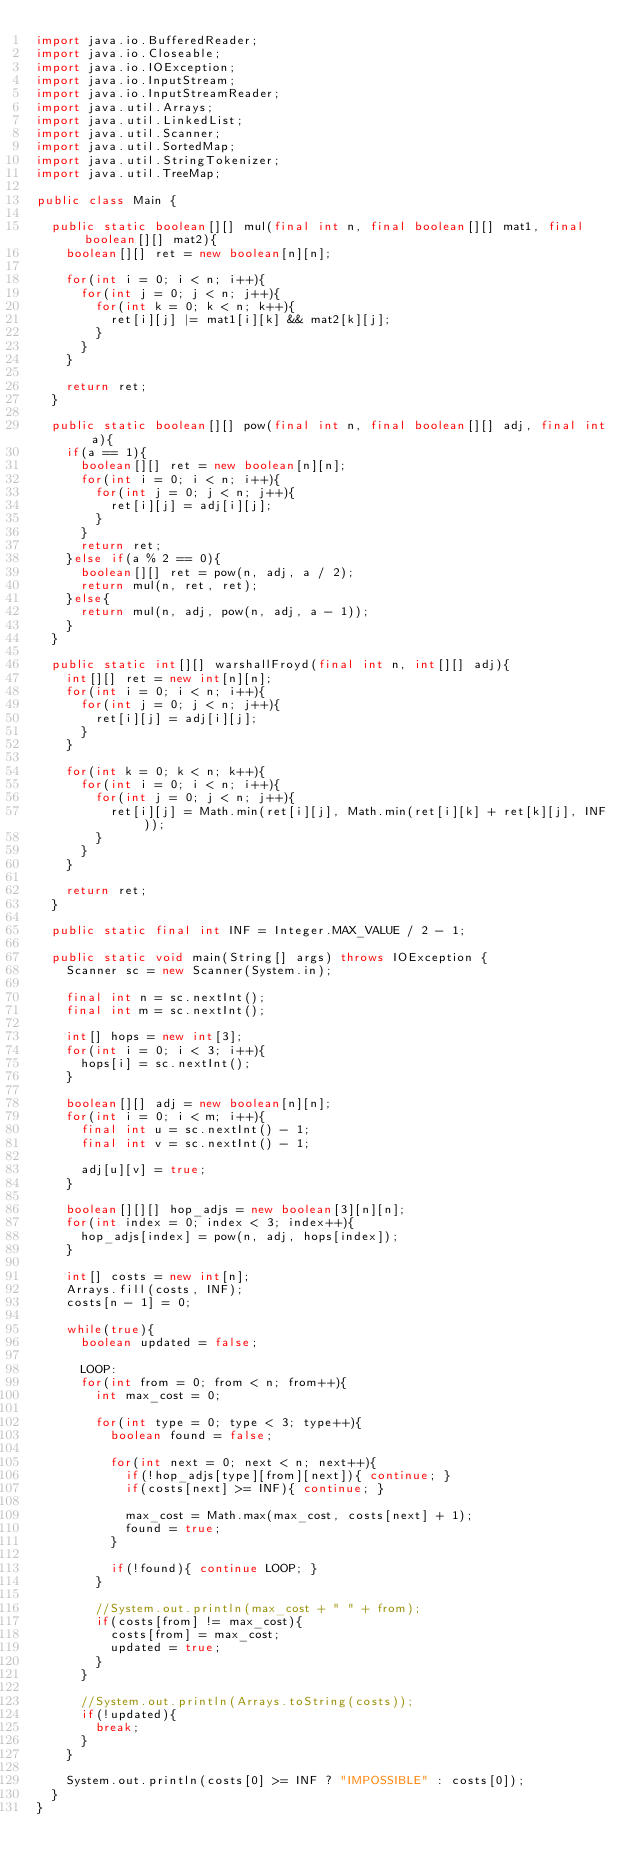<code> <loc_0><loc_0><loc_500><loc_500><_Java_>import java.io.BufferedReader;
import java.io.Closeable;
import java.io.IOException;
import java.io.InputStream;
import java.io.InputStreamReader;
import java.util.Arrays;
import java.util.LinkedList;
import java.util.Scanner;
import java.util.SortedMap;
import java.util.StringTokenizer;
import java.util.TreeMap;
 
public class Main {
	
	public static boolean[][] mul(final int n, final boolean[][] mat1, final boolean[][] mat2){
		boolean[][] ret = new boolean[n][n];
		
		for(int i = 0; i < n; i++){
			for(int j = 0; j < n; j++){
				for(int k = 0; k < n; k++){
					ret[i][j] |= mat1[i][k] && mat2[k][j];
				}
			}
		}
		
		return ret;
	}
	
	public static boolean[][] pow(final int n, final boolean[][] adj, final int a){
		if(a == 1){
			boolean[][] ret = new boolean[n][n];
			for(int i = 0; i < n; i++){
				for(int j = 0; j < n; j++){
					ret[i][j] = adj[i][j];
				}
			}
			return ret;
		}else if(a % 2 == 0){
			boolean[][] ret = pow(n, adj, a / 2);
			return mul(n, ret, ret);
		}else{
			return mul(n, adj, pow(n, adj, a - 1));
		}
	}
	
	public static int[][] warshallFroyd(final int n, int[][] adj){
		int[][] ret = new int[n][n];
		for(int i = 0; i < n; i++){
			for(int j = 0; j < n; j++){
				ret[i][j] = adj[i][j];
			}
		}
		
		for(int k = 0; k < n; k++){
			for(int i = 0; i < n; i++){
				for(int j = 0; j < n; j++){
					ret[i][j] = Math.min(ret[i][j], Math.min(ret[i][k] + ret[k][j], INF));
				}
			}
		}
		
		return ret;
	}
	
	public static final int INF = Integer.MAX_VALUE / 2 - 1;
	
	public static void main(String[] args) throws IOException {
		Scanner sc = new Scanner(System.in);
		
		final int n = sc.nextInt();
		final int m = sc.nextInt();
		
		int[] hops = new int[3];
		for(int i = 0; i < 3; i++){
			hops[i] = sc.nextInt();
		}
		
		boolean[][] adj = new boolean[n][n];
		for(int i = 0; i < m; i++){
			final int u = sc.nextInt() - 1;
			final int v = sc.nextInt() - 1;
			
			adj[u][v] = true;
		}
		
		boolean[][][] hop_adjs = new boolean[3][n][n];
		for(int index = 0; index < 3; index++){
			hop_adjs[index] = pow(n, adj, hops[index]);
		}
		
		int[] costs = new int[n];
		Arrays.fill(costs, INF);
		costs[n - 1] = 0;
		
		while(true){
			boolean updated = false;
			
			LOOP:
			for(int from = 0; from < n; from++){
				int max_cost = 0;
				
				for(int type = 0; type < 3; type++){
					boolean found = false;
					
					for(int next = 0; next < n; next++){
						if(!hop_adjs[type][from][next]){ continue; }
						if(costs[next] >= INF){ continue; }
						
						max_cost = Math.max(max_cost, costs[next] + 1);
						found = true;
					}
					
					if(!found){ continue LOOP; }
				}
				
				//System.out.println(max_cost + " " + from);
				if(costs[from] != max_cost){
					costs[from] = max_cost;
					updated = true;
				}
			}
			
			//System.out.println(Arrays.toString(costs));
			if(!updated){
				break;
			}
		}
		
		System.out.println(costs[0] >= INF ? "IMPOSSIBLE" : costs[0]);
	}
}</code> 